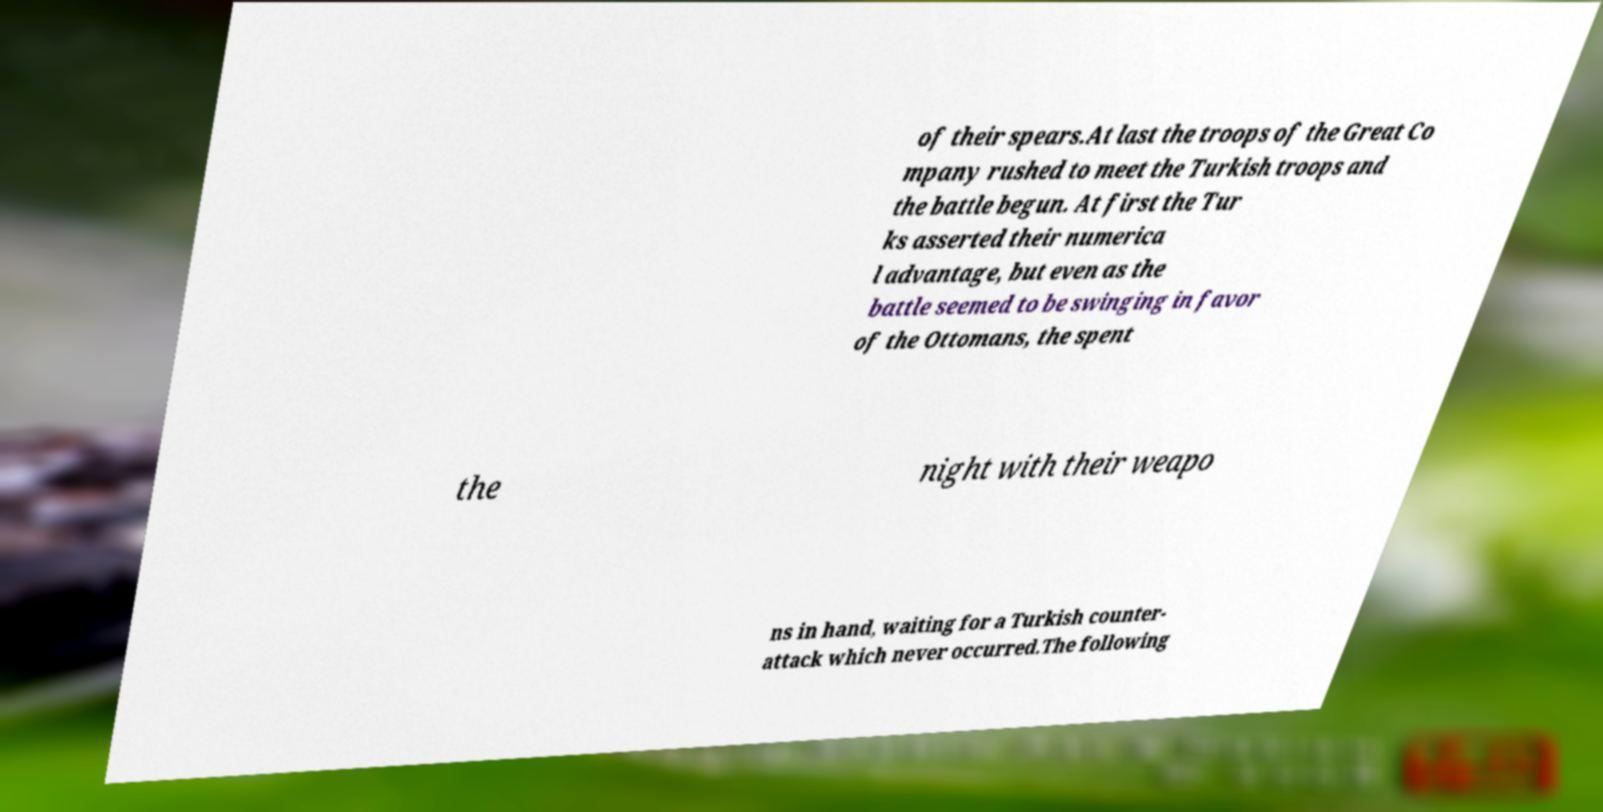There's text embedded in this image that I need extracted. Can you transcribe it verbatim? of their spears.At last the troops of the Great Co mpany rushed to meet the Turkish troops and the battle begun. At first the Tur ks asserted their numerica l advantage, but even as the battle seemed to be swinging in favor of the Ottomans, the spent the night with their weapo ns in hand, waiting for a Turkish counter- attack which never occurred.The following 